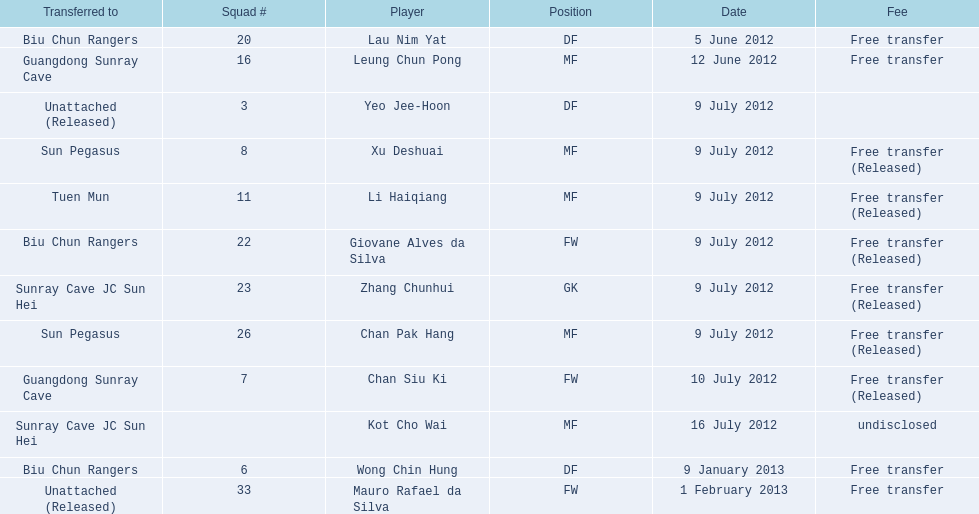What is the total number of players listed? 12. 